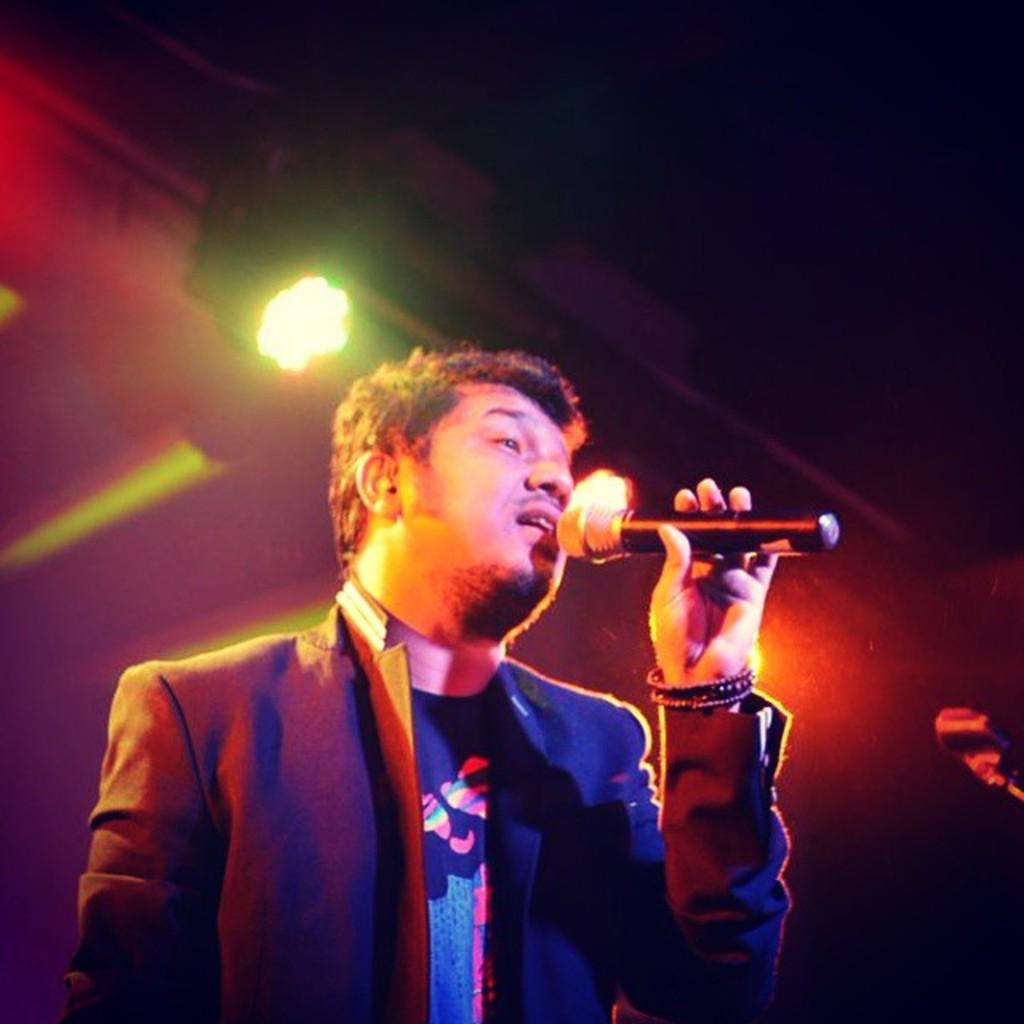What is the person in the image holding? The person is holding a microphone in the image. What else can be seen beside the person? There is an object beside the person. What can be seen at the top of the image? There are lights visible at the top of the image. What is the opinion of the committee in the image? There is no committee or opinion present in the image; it only features a person holding a microphone and an object beside them. 